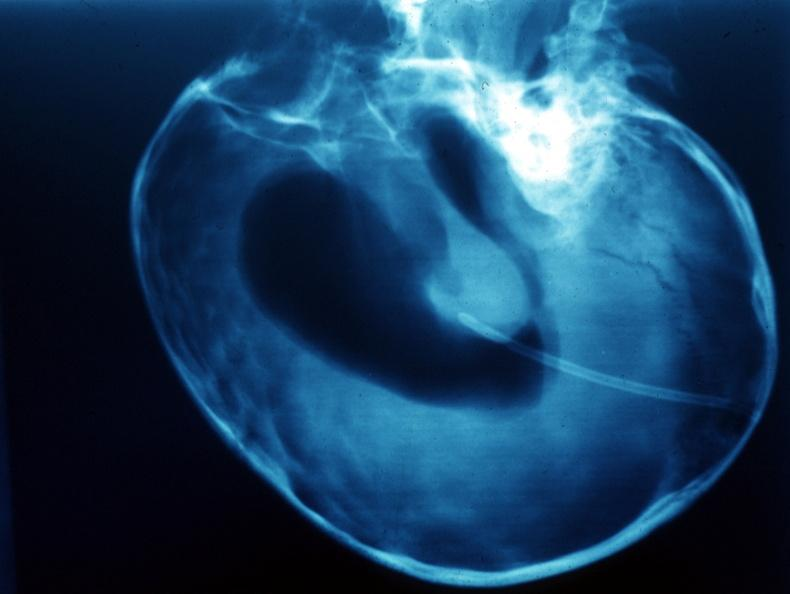what is present?
Answer the question using a single word or phrase. Craniopharyngioma 